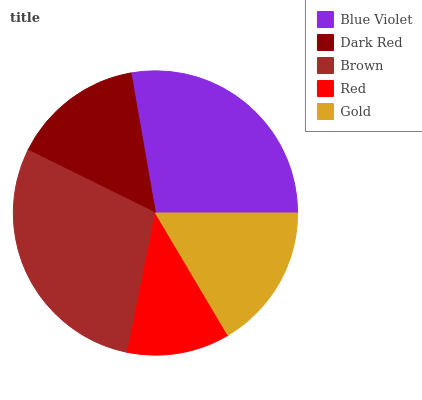Is Red the minimum?
Answer yes or no. Yes. Is Brown the maximum?
Answer yes or no. Yes. Is Dark Red the minimum?
Answer yes or no. No. Is Dark Red the maximum?
Answer yes or no. No. Is Blue Violet greater than Dark Red?
Answer yes or no. Yes. Is Dark Red less than Blue Violet?
Answer yes or no. Yes. Is Dark Red greater than Blue Violet?
Answer yes or no. No. Is Blue Violet less than Dark Red?
Answer yes or no. No. Is Gold the high median?
Answer yes or no. Yes. Is Gold the low median?
Answer yes or no. Yes. Is Brown the high median?
Answer yes or no. No. Is Blue Violet the low median?
Answer yes or no. No. 